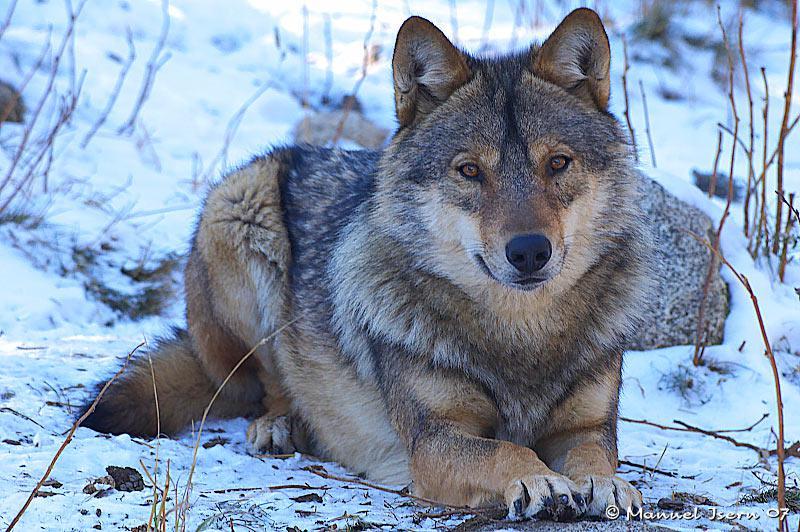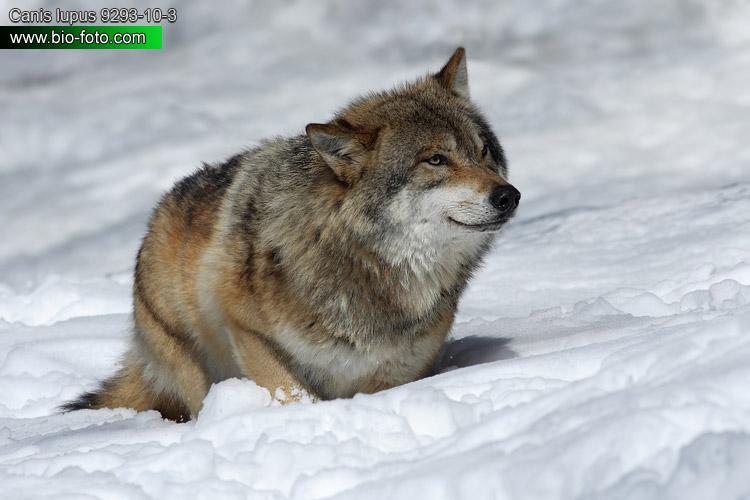The first image is the image on the left, the second image is the image on the right. For the images shown, is this caption "Each image contains a single wolf, and the left image features a wolf reclining on the snow with its body angled rightward." true? Answer yes or no. Yes. The first image is the image on the left, the second image is the image on the right. Considering the images on both sides, is "In each image the terrain around the wolf is covered in snow." valid? Answer yes or no. Yes. 